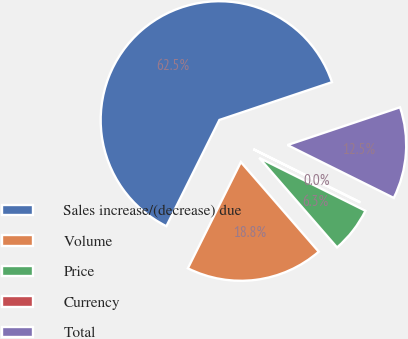Convert chart. <chart><loc_0><loc_0><loc_500><loc_500><pie_chart><fcel>Sales increase/(decrease) due<fcel>Volume<fcel>Price<fcel>Currency<fcel>Total<nl><fcel>62.48%<fcel>18.75%<fcel>6.26%<fcel>0.01%<fcel>12.5%<nl></chart> 